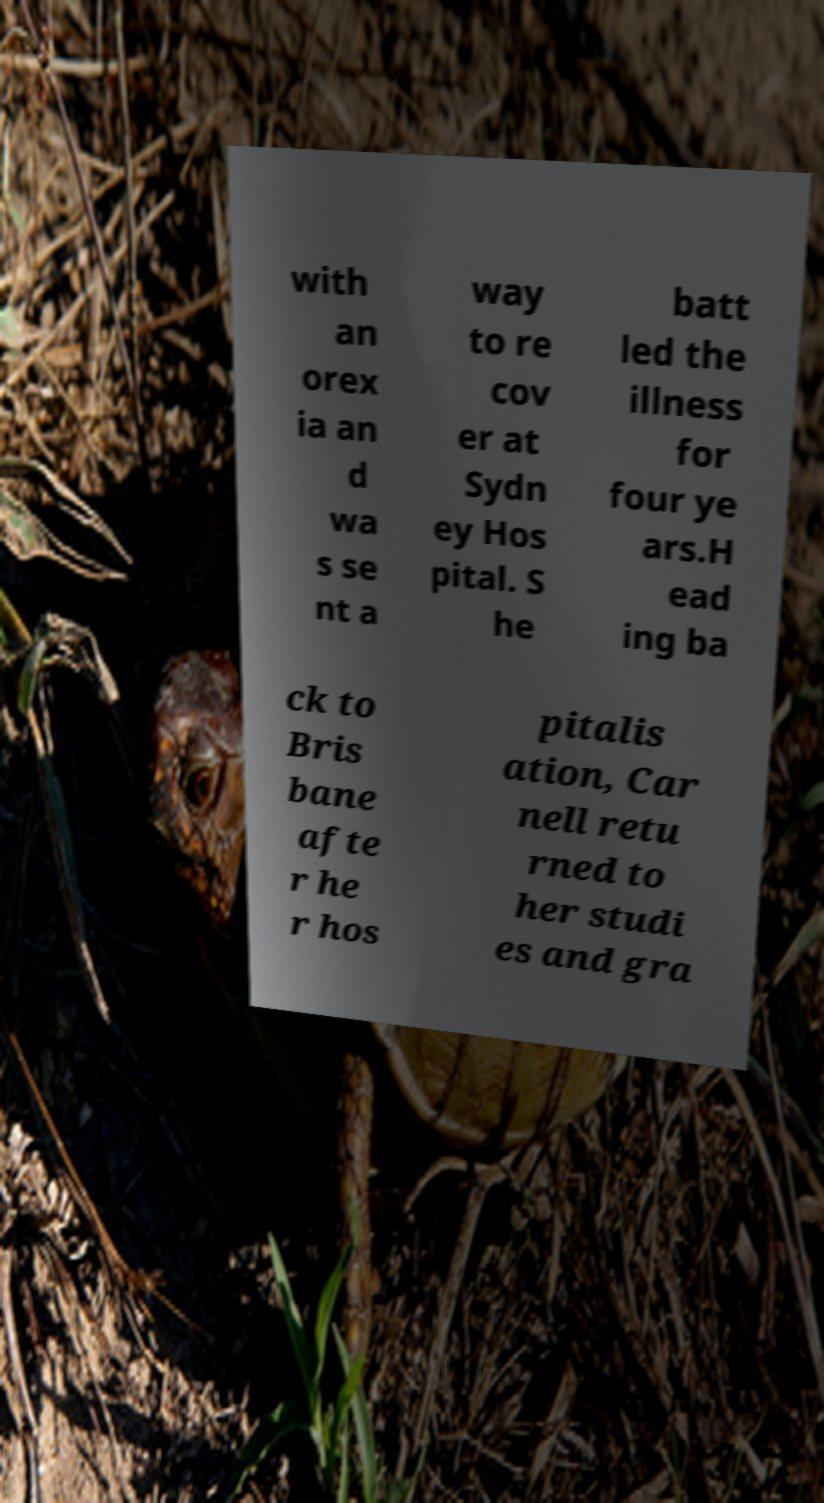Could you assist in decoding the text presented in this image and type it out clearly? with an orex ia an d wa s se nt a way to re cov er at Sydn ey Hos pital. S he batt led the illness for four ye ars.H ead ing ba ck to Bris bane afte r he r hos pitalis ation, Car nell retu rned to her studi es and gra 